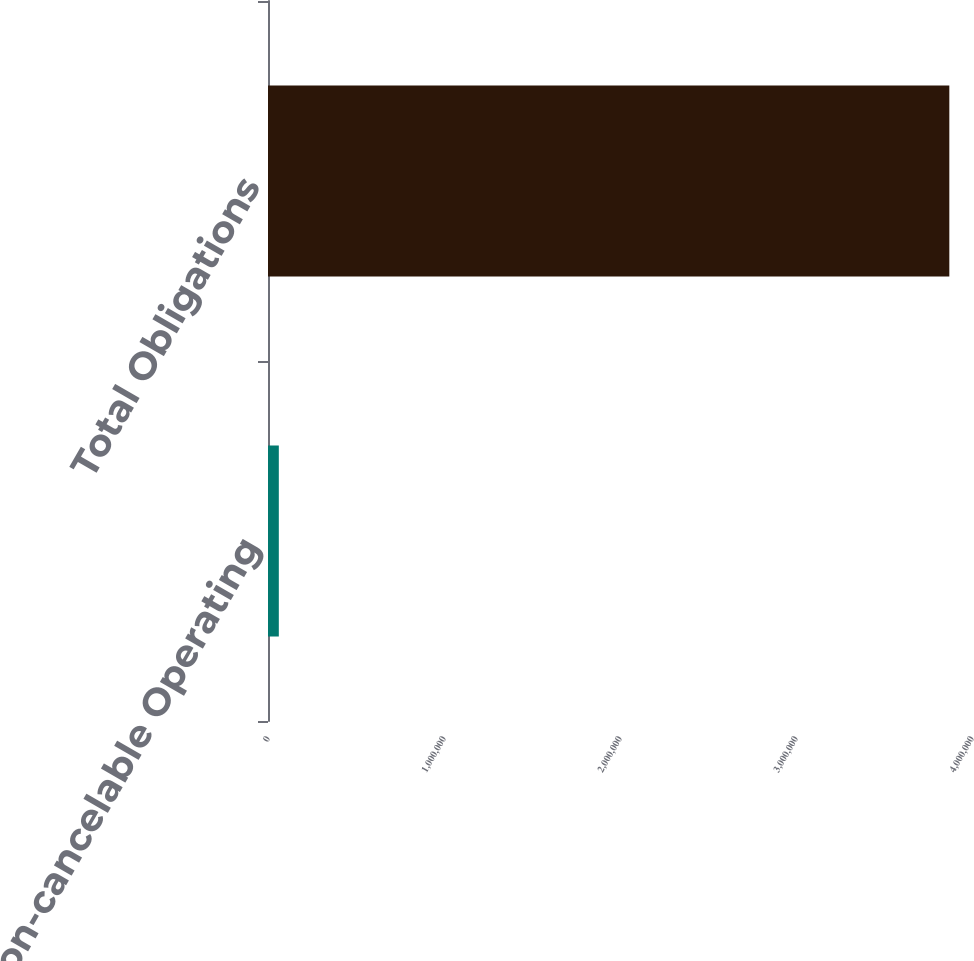<chart> <loc_0><loc_0><loc_500><loc_500><bar_chart><fcel>Non-cancelable Operating<fcel>Total Obligations<nl><fcel>61492<fcel>3.87117e+06<nl></chart> 